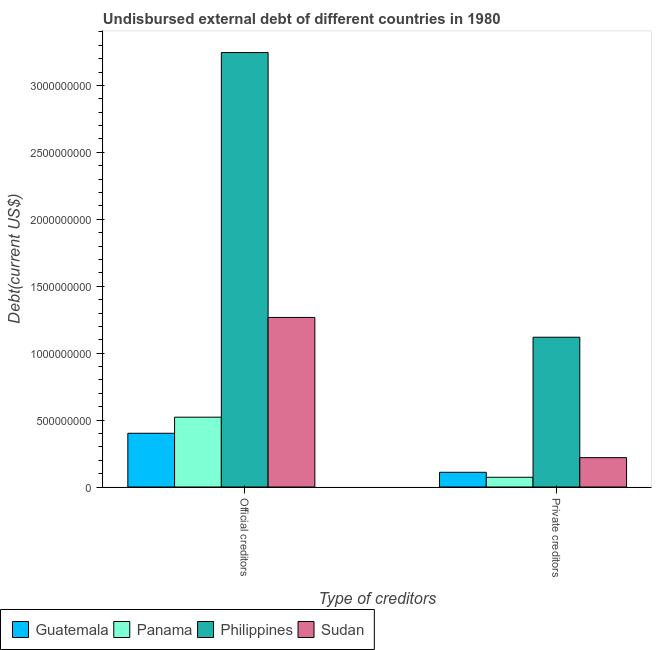How many different coloured bars are there?
Offer a very short reply. 4. How many groups of bars are there?
Your answer should be compact. 2. Are the number of bars on each tick of the X-axis equal?
Keep it short and to the point. Yes. How many bars are there on the 2nd tick from the right?
Your answer should be very brief. 4. What is the label of the 2nd group of bars from the left?
Give a very brief answer. Private creditors. What is the undisbursed external debt of private creditors in Panama?
Your answer should be very brief. 7.28e+07. Across all countries, what is the maximum undisbursed external debt of official creditors?
Make the answer very short. 3.25e+09. Across all countries, what is the minimum undisbursed external debt of private creditors?
Ensure brevity in your answer.  7.28e+07. In which country was the undisbursed external debt of private creditors maximum?
Your response must be concise. Philippines. In which country was the undisbursed external debt of private creditors minimum?
Your response must be concise. Panama. What is the total undisbursed external debt of private creditors in the graph?
Make the answer very short. 1.52e+09. What is the difference between the undisbursed external debt of official creditors in Guatemala and that in Panama?
Give a very brief answer. -1.20e+08. What is the difference between the undisbursed external debt of private creditors in Sudan and the undisbursed external debt of official creditors in Guatemala?
Keep it short and to the point. -1.82e+08. What is the average undisbursed external debt of official creditors per country?
Provide a short and direct response. 1.36e+09. What is the difference between the undisbursed external debt of private creditors and undisbursed external debt of official creditors in Guatemala?
Keep it short and to the point. -2.92e+08. In how many countries, is the undisbursed external debt of private creditors greater than 1100000000 US$?
Give a very brief answer. 1. What is the ratio of the undisbursed external debt of official creditors in Panama to that in Philippines?
Keep it short and to the point. 0.16. What does the 4th bar from the left in Private creditors represents?
Your answer should be compact. Sudan. What does the 1st bar from the right in Private creditors represents?
Provide a succinct answer. Sudan. How many bars are there?
Ensure brevity in your answer.  8. How many countries are there in the graph?
Your answer should be compact. 4. Does the graph contain grids?
Your answer should be very brief. No. Where does the legend appear in the graph?
Your answer should be compact. Bottom left. How are the legend labels stacked?
Your response must be concise. Horizontal. What is the title of the graph?
Offer a terse response. Undisbursed external debt of different countries in 1980. What is the label or title of the X-axis?
Make the answer very short. Type of creditors. What is the label or title of the Y-axis?
Provide a short and direct response. Debt(current US$). What is the Debt(current US$) in Guatemala in Official creditors?
Keep it short and to the point. 4.02e+08. What is the Debt(current US$) of Panama in Official creditors?
Your response must be concise. 5.22e+08. What is the Debt(current US$) of Philippines in Official creditors?
Ensure brevity in your answer.  3.25e+09. What is the Debt(current US$) of Sudan in Official creditors?
Give a very brief answer. 1.27e+09. What is the Debt(current US$) of Guatemala in Private creditors?
Ensure brevity in your answer.  1.10e+08. What is the Debt(current US$) in Panama in Private creditors?
Provide a succinct answer. 7.28e+07. What is the Debt(current US$) of Philippines in Private creditors?
Offer a terse response. 1.12e+09. What is the Debt(current US$) in Sudan in Private creditors?
Make the answer very short. 2.19e+08. Across all Type of creditors, what is the maximum Debt(current US$) of Guatemala?
Offer a very short reply. 4.02e+08. Across all Type of creditors, what is the maximum Debt(current US$) in Panama?
Provide a succinct answer. 5.22e+08. Across all Type of creditors, what is the maximum Debt(current US$) of Philippines?
Keep it short and to the point. 3.25e+09. Across all Type of creditors, what is the maximum Debt(current US$) of Sudan?
Offer a terse response. 1.27e+09. Across all Type of creditors, what is the minimum Debt(current US$) in Guatemala?
Offer a very short reply. 1.10e+08. Across all Type of creditors, what is the minimum Debt(current US$) of Panama?
Make the answer very short. 7.28e+07. Across all Type of creditors, what is the minimum Debt(current US$) of Philippines?
Your answer should be compact. 1.12e+09. Across all Type of creditors, what is the minimum Debt(current US$) of Sudan?
Give a very brief answer. 2.19e+08. What is the total Debt(current US$) of Guatemala in the graph?
Offer a very short reply. 5.12e+08. What is the total Debt(current US$) in Panama in the graph?
Your answer should be very brief. 5.94e+08. What is the total Debt(current US$) in Philippines in the graph?
Your response must be concise. 4.36e+09. What is the total Debt(current US$) in Sudan in the graph?
Make the answer very short. 1.49e+09. What is the difference between the Debt(current US$) in Guatemala in Official creditors and that in Private creditors?
Offer a very short reply. 2.92e+08. What is the difference between the Debt(current US$) of Panama in Official creditors and that in Private creditors?
Offer a terse response. 4.49e+08. What is the difference between the Debt(current US$) of Philippines in Official creditors and that in Private creditors?
Your response must be concise. 2.13e+09. What is the difference between the Debt(current US$) in Sudan in Official creditors and that in Private creditors?
Offer a terse response. 1.05e+09. What is the difference between the Debt(current US$) of Guatemala in Official creditors and the Debt(current US$) of Panama in Private creditors?
Your answer should be compact. 3.29e+08. What is the difference between the Debt(current US$) of Guatemala in Official creditors and the Debt(current US$) of Philippines in Private creditors?
Provide a succinct answer. -7.17e+08. What is the difference between the Debt(current US$) in Guatemala in Official creditors and the Debt(current US$) in Sudan in Private creditors?
Make the answer very short. 1.82e+08. What is the difference between the Debt(current US$) in Panama in Official creditors and the Debt(current US$) in Philippines in Private creditors?
Your answer should be compact. -5.97e+08. What is the difference between the Debt(current US$) in Panama in Official creditors and the Debt(current US$) in Sudan in Private creditors?
Your answer should be very brief. 3.02e+08. What is the difference between the Debt(current US$) of Philippines in Official creditors and the Debt(current US$) of Sudan in Private creditors?
Provide a succinct answer. 3.03e+09. What is the average Debt(current US$) of Guatemala per Type of creditors?
Provide a short and direct response. 2.56e+08. What is the average Debt(current US$) of Panama per Type of creditors?
Offer a terse response. 2.97e+08. What is the average Debt(current US$) in Philippines per Type of creditors?
Offer a very short reply. 2.18e+09. What is the average Debt(current US$) in Sudan per Type of creditors?
Ensure brevity in your answer.  7.43e+08. What is the difference between the Debt(current US$) in Guatemala and Debt(current US$) in Panama in Official creditors?
Provide a succinct answer. -1.20e+08. What is the difference between the Debt(current US$) in Guatemala and Debt(current US$) in Philippines in Official creditors?
Your answer should be very brief. -2.84e+09. What is the difference between the Debt(current US$) of Guatemala and Debt(current US$) of Sudan in Official creditors?
Provide a short and direct response. -8.65e+08. What is the difference between the Debt(current US$) in Panama and Debt(current US$) in Philippines in Official creditors?
Your answer should be compact. -2.72e+09. What is the difference between the Debt(current US$) in Panama and Debt(current US$) in Sudan in Official creditors?
Keep it short and to the point. -7.45e+08. What is the difference between the Debt(current US$) in Philippines and Debt(current US$) in Sudan in Official creditors?
Give a very brief answer. 1.98e+09. What is the difference between the Debt(current US$) in Guatemala and Debt(current US$) in Panama in Private creditors?
Offer a very short reply. 3.72e+07. What is the difference between the Debt(current US$) in Guatemala and Debt(current US$) in Philippines in Private creditors?
Ensure brevity in your answer.  -1.01e+09. What is the difference between the Debt(current US$) of Guatemala and Debt(current US$) of Sudan in Private creditors?
Provide a short and direct response. -1.09e+08. What is the difference between the Debt(current US$) of Panama and Debt(current US$) of Philippines in Private creditors?
Your response must be concise. -1.05e+09. What is the difference between the Debt(current US$) of Panama and Debt(current US$) of Sudan in Private creditors?
Your response must be concise. -1.47e+08. What is the difference between the Debt(current US$) in Philippines and Debt(current US$) in Sudan in Private creditors?
Offer a very short reply. 9.00e+08. What is the ratio of the Debt(current US$) of Guatemala in Official creditors to that in Private creditors?
Provide a short and direct response. 3.65. What is the ratio of the Debt(current US$) of Panama in Official creditors to that in Private creditors?
Provide a succinct answer. 7.17. What is the ratio of the Debt(current US$) in Philippines in Official creditors to that in Private creditors?
Offer a very short reply. 2.9. What is the ratio of the Debt(current US$) in Sudan in Official creditors to that in Private creditors?
Your answer should be compact. 5.77. What is the difference between the highest and the second highest Debt(current US$) of Guatemala?
Your response must be concise. 2.92e+08. What is the difference between the highest and the second highest Debt(current US$) of Panama?
Your answer should be compact. 4.49e+08. What is the difference between the highest and the second highest Debt(current US$) of Philippines?
Give a very brief answer. 2.13e+09. What is the difference between the highest and the second highest Debt(current US$) of Sudan?
Ensure brevity in your answer.  1.05e+09. What is the difference between the highest and the lowest Debt(current US$) in Guatemala?
Ensure brevity in your answer.  2.92e+08. What is the difference between the highest and the lowest Debt(current US$) of Panama?
Your answer should be compact. 4.49e+08. What is the difference between the highest and the lowest Debt(current US$) in Philippines?
Make the answer very short. 2.13e+09. What is the difference between the highest and the lowest Debt(current US$) of Sudan?
Your answer should be compact. 1.05e+09. 